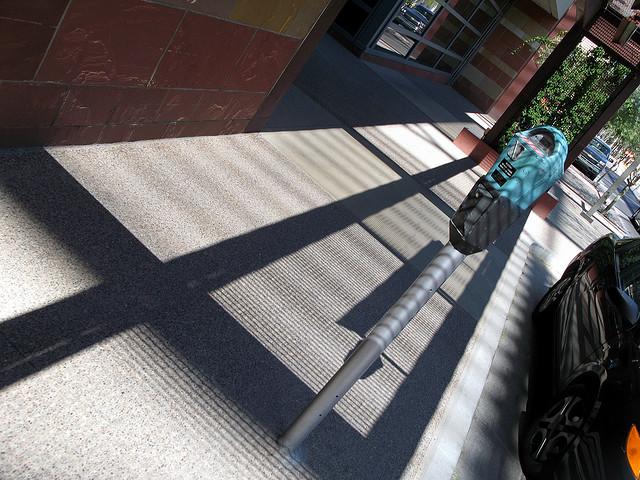Is this a colorful scene?
Keep it brief. Yes. What color is the meter?
Keep it brief. Blue. What object is this?
Be succinct. Parking meter. Is the plant real?
Keep it brief. Yes. What kind of truck is in the background?
Be succinct. Van. 